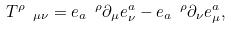Convert formula to latex. <formula><loc_0><loc_0><loc_500><loc_500>T ^ { \rho } \text { } _ { \mu \nu } = e _ { a } \text { } ^ { \rho } \partial _ { \mu } e _ { \nu } ^ { a } - e _ { a } \text { } ^ { \rho } \partial _ { \nu } e _ { \mu } ^ { a } ,</formula> 